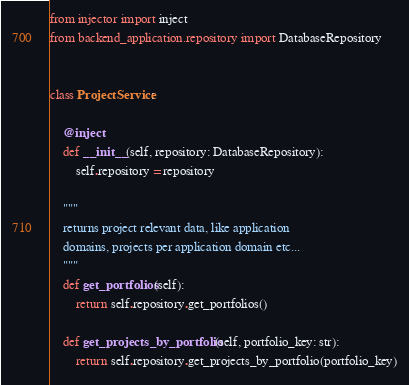Convert code to text. <code><loc_0><loc_0><loc_500><loc_500><_Python_>from injector import inject
from backend_application.repository import DatabaseRepository


class ProjectService:

    @inject
    def __init__(self, repository: DatabaseRepository):
        self.repository = repository

    """
    returns project relevant data, like application
    domains, projects per application domain etc...
    """
    def get_portfolios(self):
        return self.repository.get_portfolios()

    def get_projects_by_portfolio(self, portfolio_key: str):
        return self.repository.get_projects_by_portfolio(portfolio_key)

</code> 